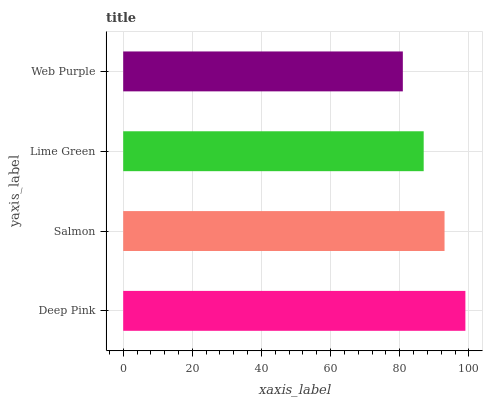Is Web Purple the minimum?
Answer yes or no. Yes. Is Deep Pink the maximum?
Answer yes or no. Yes. Is Salmon the minimum?
Answer yes or no. No. Is Salmon the maximum?
Answer yes or no. No. Is Deep Pink greater than Salmon?
Answer yes or no. Yes. Is Salmon less than Deep Pink?
Answer yes or no. Yes. Is Salmon greater than Deep Pink?
Answer yes or no. No. Is Deep Pink less than Salmon?
Answer yes or no. No. Is Salmon the high median?
Answer yes or no. Yes. Is Lime Green the low median?
Answer yes or no. Yes. Is Deep Pink the high median?
Answer yes or no. No. Is Web Purple the low median?
Answer yes or no. No. 